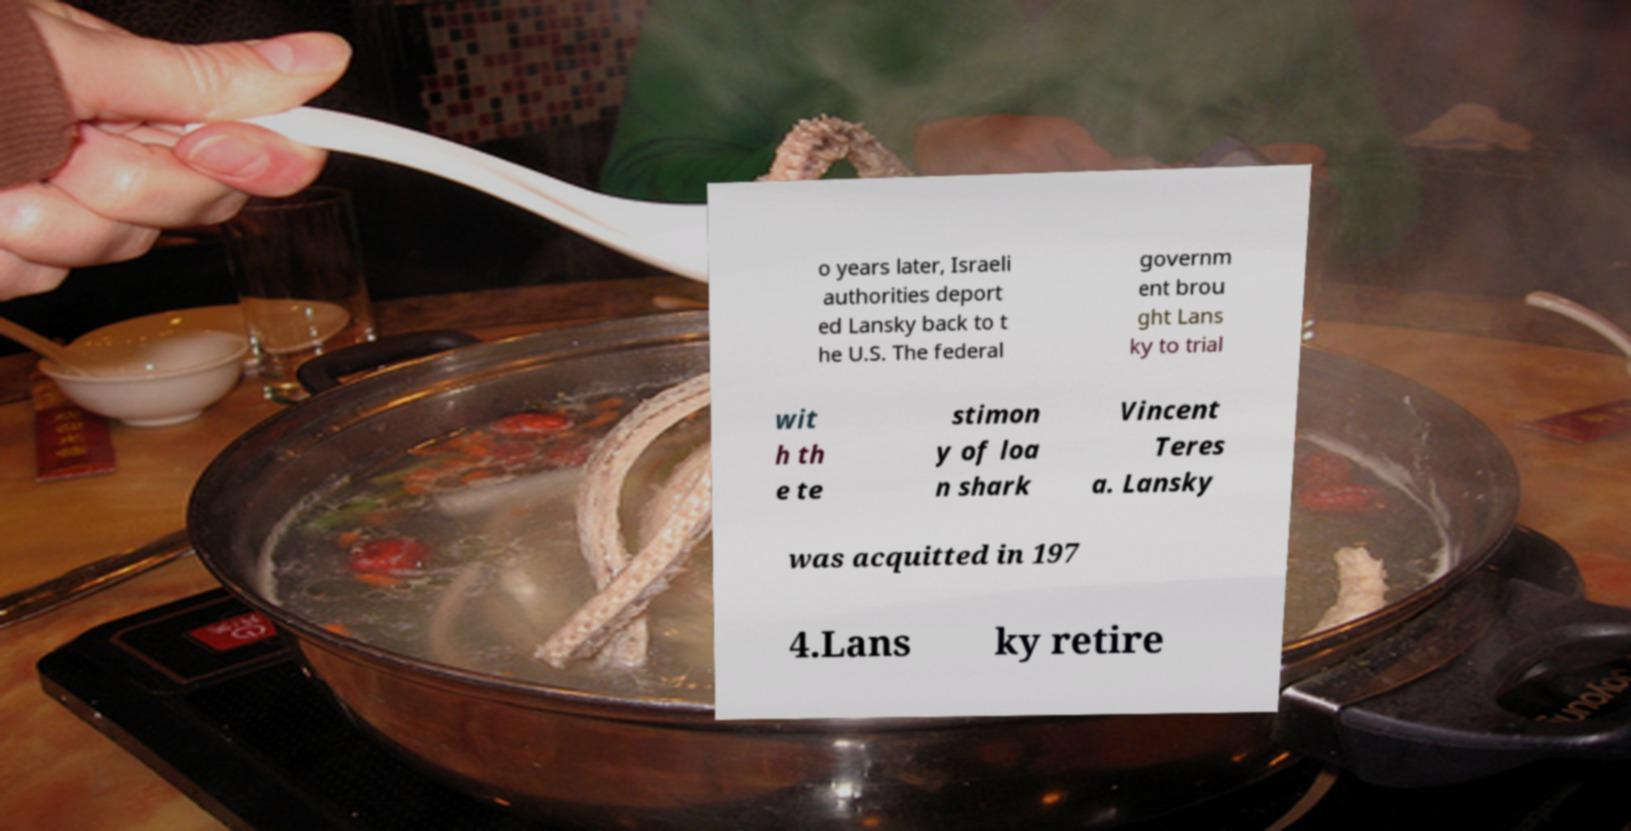Can you accurately transcribe the text from the provided image for me? o years later, Israeli authorities deport ed Lansky back to t he U.S. The federal governm ent brou ght Lans ky to trial wit h th e te stimon y of loa n shark Vincent Teres a. Lansky was acquitted in 197 4.Lans ky retire 